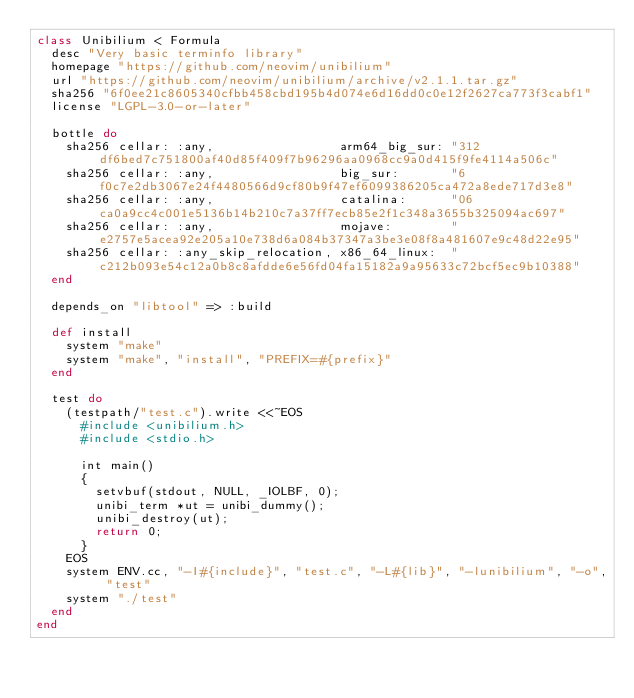<code> <loc_0><loc_0><loc_500><loc_500><_Ruby_>class Unibilium < Formula
  desc "Very basic terminfo library"
  homepage "https://github.com/neovim/unibilium"
  url "https://github.com/neovim/unibilium/archive/v2.1.1.tar.gz"
  sha256 "6f0ee21c8605340cfbb458cbd195b4d074e6d16dd0c0e12f2627ca773f3cabf1"
  license "LGPL-3.0-or-later"

  bottle do
    sha256 cellar: :any,                 arm64_big_sur: "312df6bed7c751800af40d85f409f7b96296aa0968cc9a0d415f9fe4114a506c"
    sha256 cellar: :any,                 big_sur:       "6f0c7e2db3067e24f4480566d9cf80b9f47ef6099386205ca472a8ede717d3e8"
    sha256 cellar: :any,                 catalina:      "06ca0a9cc4c001e5136b14b210c7a37ff7ecb85e2f1c348a3655b325094ac697"
    sha256 cellar: :any,                 mojave:        "e2757e5acea92e205a10e738d6a084b37347a3be3e08f8a481607e9c48d22e95"
    sha256 cellar: :any_skip_relocation, x86_64_linux:  "c212b093e54c12a0b8c8afdde6e56fd04fa15182a9a95633c72bcf5ec9b10388"
  end

  depends_on "libtool" => :build

  def install
    system "make"
    system "make", "install", "PREFIX=#{prefix}"
  end

  test do
    (testpath/"test.c").write <<~EOS
      #include <unibilium.h>
      #include <stdio.h>

      int main()
      {
        setvbuf(stdout, NULL, _IOLBF, 0);
        unibi_term *ut = unibi_dummy();
        unibi_destroy(ut);
        return 0;
      }
    EOS
    system ENV.cc, "-I#{include}", "test.c", "-L#{lib}", "-lunibilium", "-o", "test"
    system "./test"
  end
end
</code> 